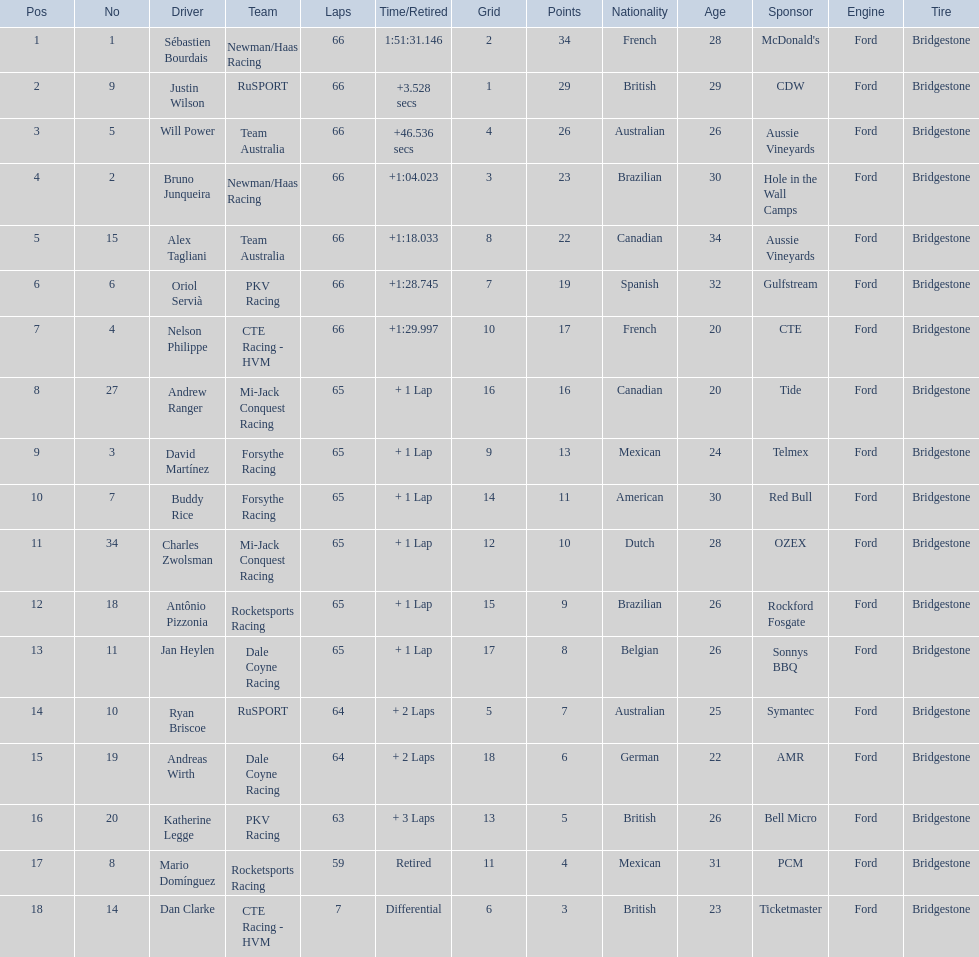Who are all of the 2006 gran premio telmex drivers? Sébastien Bourdais, Justin Wilson, Will Power, Bruno Junqueira, Alex Tagliani, Oriol Servià, Nelson Philippe, Andrew Ranger, David Martínez, Buddy Rice, Charles Zwolsman, Antônio Pizzonia, Jan Heylen, Ryan Briscoe, Andreas Wirth, Katherine Legge, Mario Domínguez, Dan Clarke. How many laps did they finish? 66, 66, 66, 66, 66, 66, 66, 65, 65, 65, 65, 65, 65, 64, 64, 63, 59, 7. What about just oriol servia and katherine legge? 66, 63. And which of those two drivers finished more laps? Oriol Servià. 